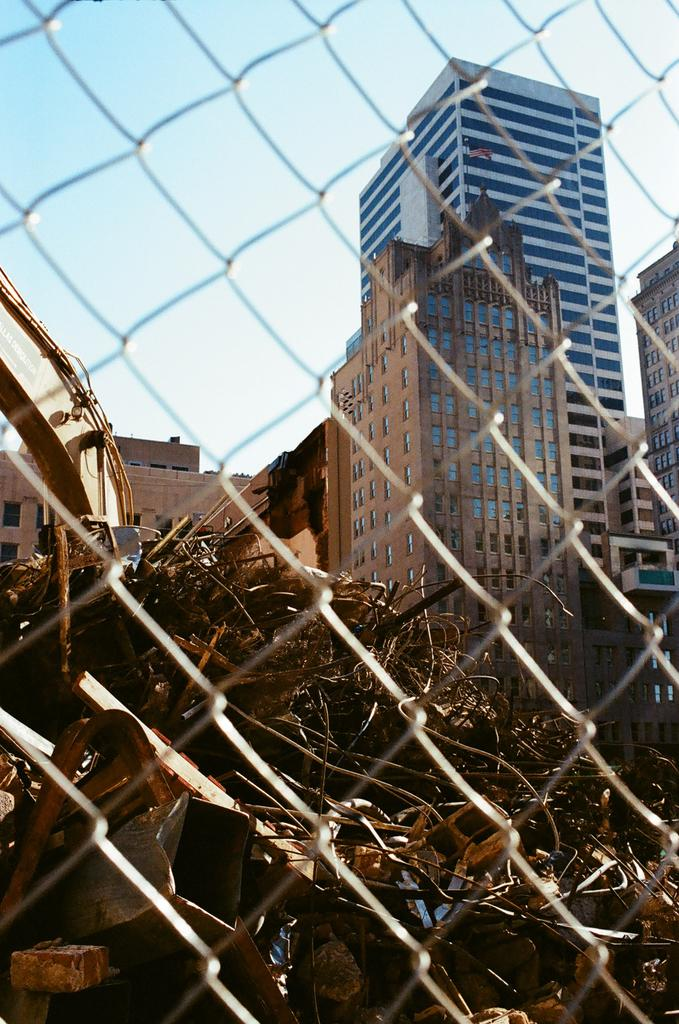What is on the ground in the image? There is a dried leaf on the ground in the image. What is located in the foreground of the image? There is a net in the foreground of the image. What can be seen in the background of the image? There are buildings and the sky visible in the background of the image. How much does the bone weigh in the image? There is no bone present in the image, so it is not possible to determine its weight. 